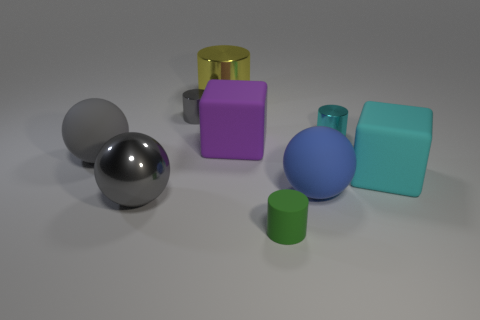Do the ball to the right of the big shiny cylinder and the purple object have the same material?
Provide a short and direct response. Yes. Are there fewer small gray shiny objects behind the large blue ball than metallic objects?
Offer a terse response. Yes. Is there a green thing that has the same material as the cyan block?
Your response must be concise. Yes. Does the green matte cylinder have the same size as the cyan object behind the large cyan matte block?
Your answer should be very brief. Yes. Are there any metallic things of the same color as the large cylinder?
Offer a terse response. No. Does the large cyan cube have the same material as the gray cylinder?
Your answer should be very brief. No. There is a tiny green thing; what number of blue spheres are in front of it?
Your answer should be very brief. 0. What material is the large ball that is on the left side of the large blue rubber sphere and behind the big gray shiny ball?
Your response must be concise. Rubber. What number of other brown matte cylinders have the same size as the matte cylinder?
Your answer should be very brief. 0. What is the color of the matte sphere that is right of the gray metallic thing behind the big blue object?
Your answer should be compact. Blue. 